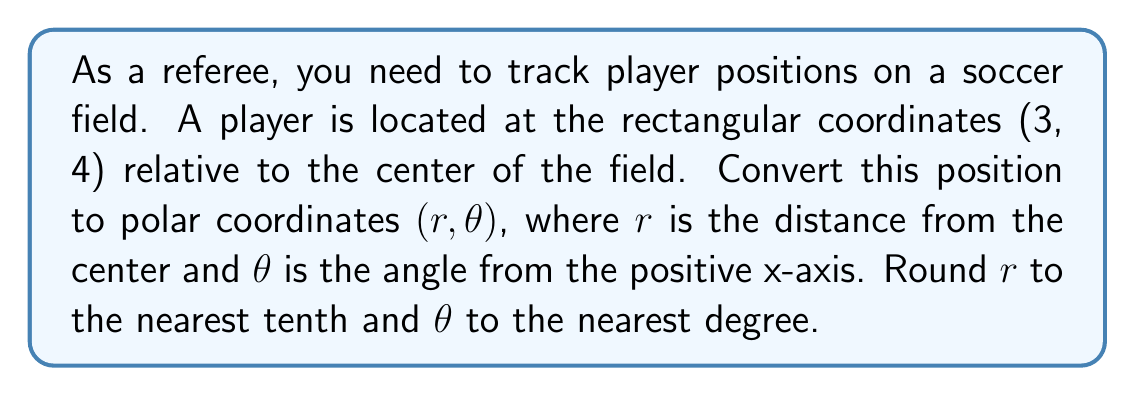What is the answer to this math problem? To convert rectangular coordinates $(x, y)$ to polar coordinates $(r, \theta)$, we use the following formulas:

1. $r = \sqrt{x^2 + y^2}$
2. $\theta = \tan^{-1}(\frac{y}{x})$

Let's solve this step-by-step:

1. Calculate $r$:
   $r = \sqrt{3^2 + 4^2} = \sqrt{9 + 16} = \sqrt{25} = 5$

2. Calculate $\theta$:
   $\theta = \tan^{-1}(\frac{4}{3}) \approx 53.13^\circ$

3. Round $r$ to the nearest tenth:
   $r \approx 5.0$

4. Round $\theta$ to the nearest degree:
   $\theta \approx 53^\circ$

Note: As a referee, understanding polar coordinates can help you quickly determine a player's distance from the center of the field (r) and their angular position (θ), which can be useful for making offside calls or assessing player positioning.

[asy]
import geometry;

unitsize(30);
draw((-3,-3)--(3,3),arrow=Arrow(TeXHead));
draw((-3,0)--(3,0),arrow=Arrow(TeXHead));
draw((0,-3)--(0,3),arrow=Arrow(TeXHead));

dot((3,4));
draw((0,0)--(3,4),arrow=Arrow(TeXHead));
draw(arc((0,0),0.8,0,53),arrow=Arrow(TeXHead));

label("x", (3,0), SE);
label("y", (0,3), NW);
label("(3,4)", (3,4), NE);
label("r", (1.5,2), NW);
label("θ", (0.6,0.3), NE);
[/asy]
Answer: $(r, \theta) \approx (5.0, 53^\circ)$ 